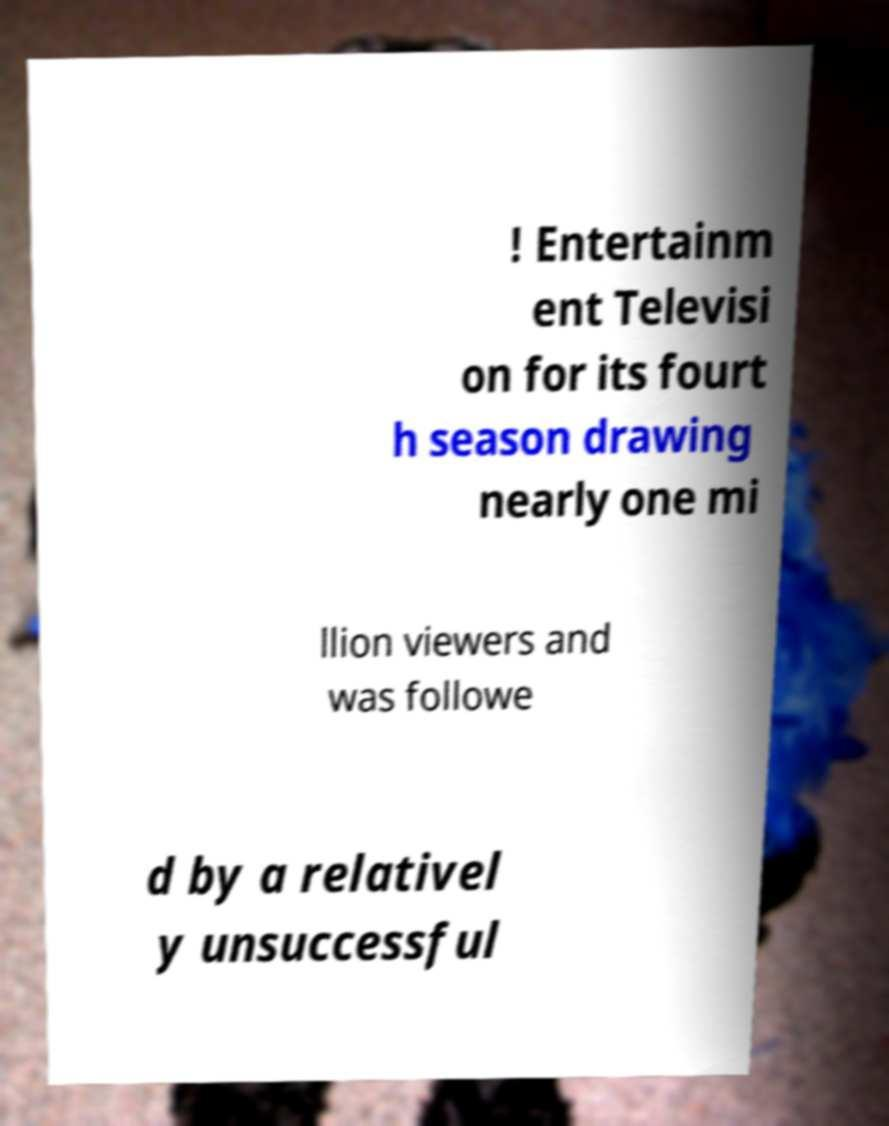Can you accurately transcribe the text from the provided image for me? ! Entertainm ent Televisi on for its fourt h season drawing nearly one mi llion viewers and was followe d by a relativel y unsuccessful 